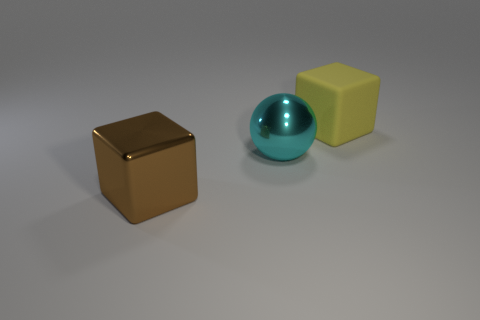Are there any other things that are the same material as the big yellow object?
Give a very brief answer. No. How many other brown cubes are the same material as the large brown cube?
Offer a very short reply. 0. Are there any blocks that are behind the big cube on the left side of the cube that is behind the large brown shiny object?
Provide a short and direct response. Yes. The thing that is made of the same material as the large brown cube is what shape?
Your answer should be compact. Sphere. Are there more brown cubes than tiny brown matte spheres?
Make the answer very short. Yes. Do the big yellow thing and the big metal thing that is in front of the big sphere have the same shape?
Provide a succinct answer. Yes. What material is the big brown block?
Your answer should be compact. Metal. What color is the cube behind the shiny object in front of the large metallic thing right of the brown metal block?
Make the answer very short. Yellow. There is another large object that is the same shape as the brown metal thing; what material is it?
Ensure brevity in your answer.  Rubber. What number of cyan metal things have the same size as the shiny sphere?
Provide a short and direct response. 0. 